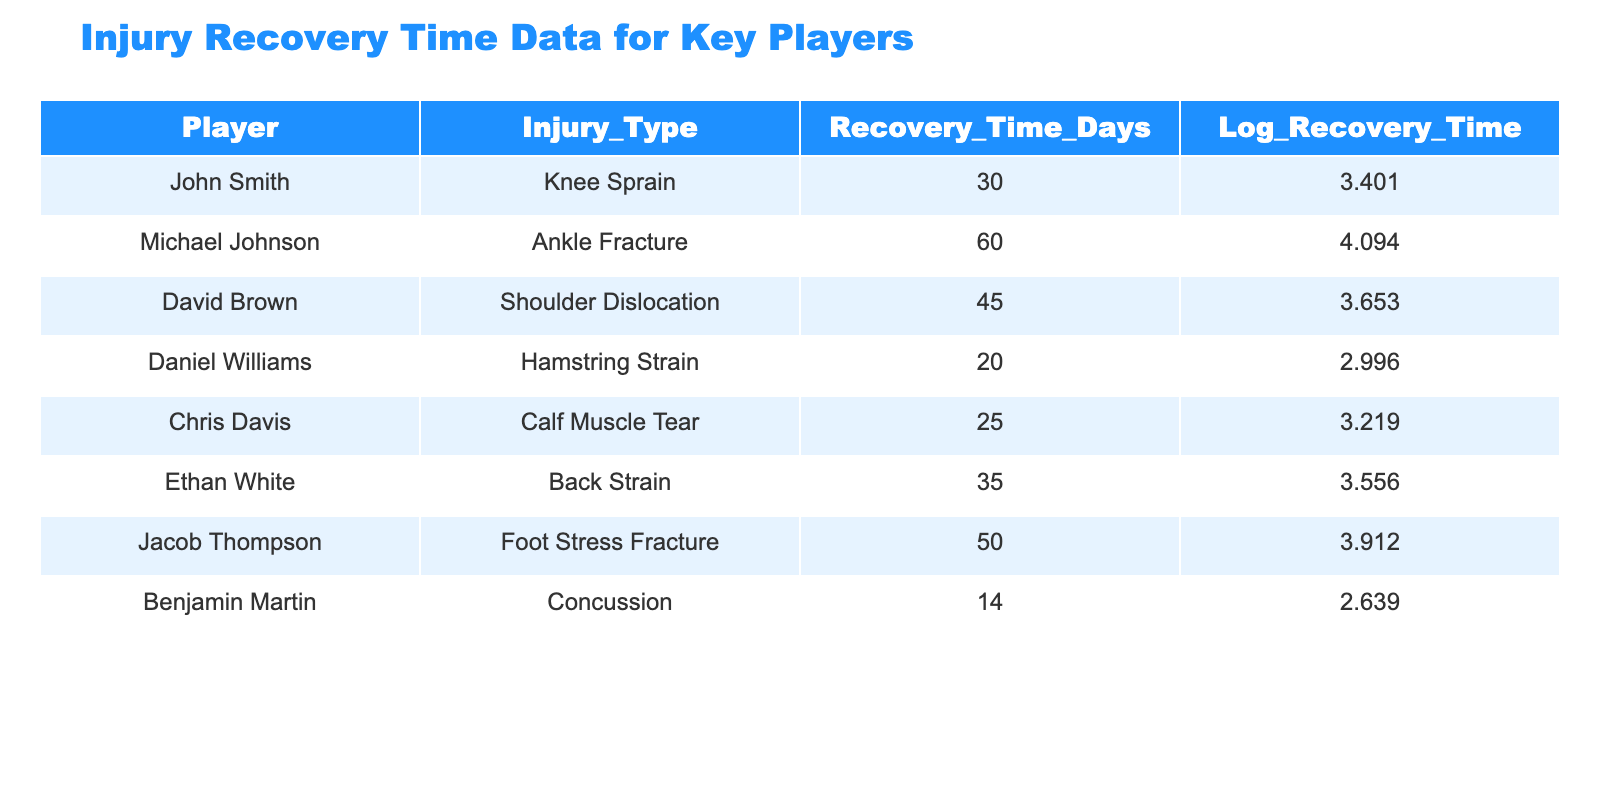What is the recovery time for Michael Johnson? The table directly shows that Michael Johnson has a recovery time of 60 days due to an ankle fracture.
Answer: 60 days Which player has the longest recovery time? Upon reviewing the recovery times, Michael Johnson (60 days) has the longest recovery time compared to the other players listed.
Answer: Michael Johnson What is the total recovery time of all players combined? Adding all the recovery times: 30 + 60 + 45 + 20 + 25 + 35 + 50 + 14 = 274 days.
Answer: 274 days Is Benjamin Martin's recovery time greater than Daniel Williams'? Comparing the two, Benjamin Martin has 14 days and Daniel Williams has 20 days. Since 14 is less than 20, the statement is false.
Answer: No What is the average recovery time of players who suffered a hamstring strain? There is only one player with a hamstring strain (Daniel Williams) with a recovery time of 20 days, thus the average recovery time is also 20 days.
Answer: 20 days Which injury type has the shortest recovery time and what is that time? The shortest recovery time is from Benjamin Martin with a concussion, at 14 days.
Answer: Concussion, 14 days What is the difference in recovery time between the player with the longest recovery time and the player with the shortest? The longest recovery time is 60 days (Michael Johnson) and the shortest is 14 days (Benjamin Martin). The difference is 60 - 14 = 46 days.
Answer: 46 days How many players have recovery times greater than 30 days? Reviewing the recovery times: John Smith (30), Michael Johnson (60), David Brown (45), Ethan White (35), Jacob Thompson (50). Four players (Michael, David, Ethan, Jacob) have recovery times greater than 30 days, not including John.
Answer: 4 players What is the logarithmic value of Daniel Williams' recovery time? The table shows that Daniel Williams' logarithmic recovery time is 2.996.
Answer: 2.996 